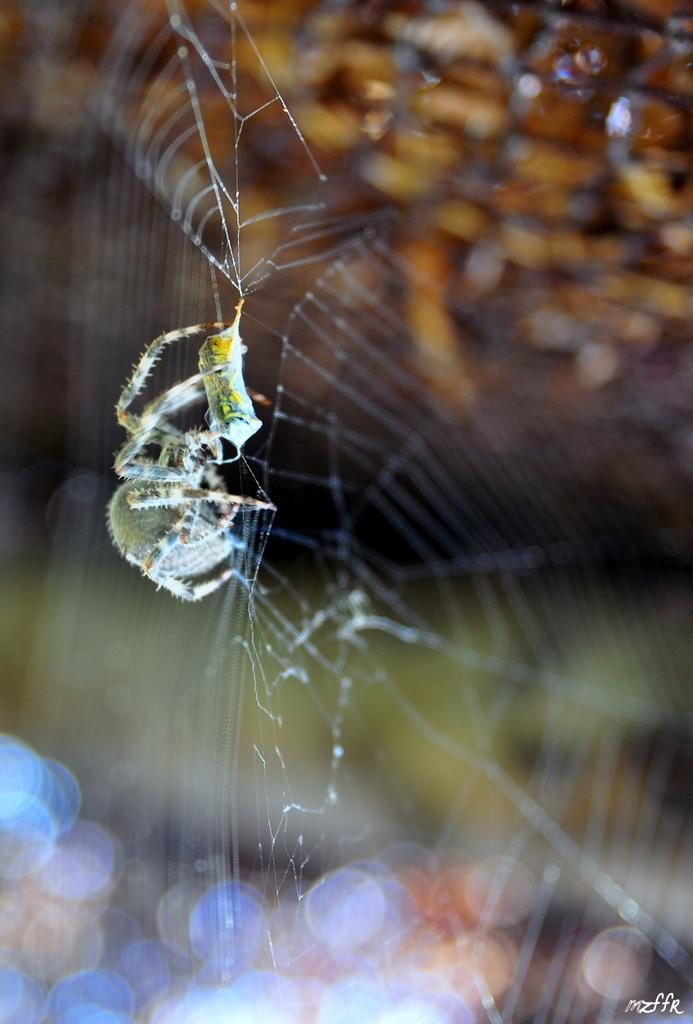Can you describe this image briefly? In this image we can see a spider on a spider web and a blurry background. 